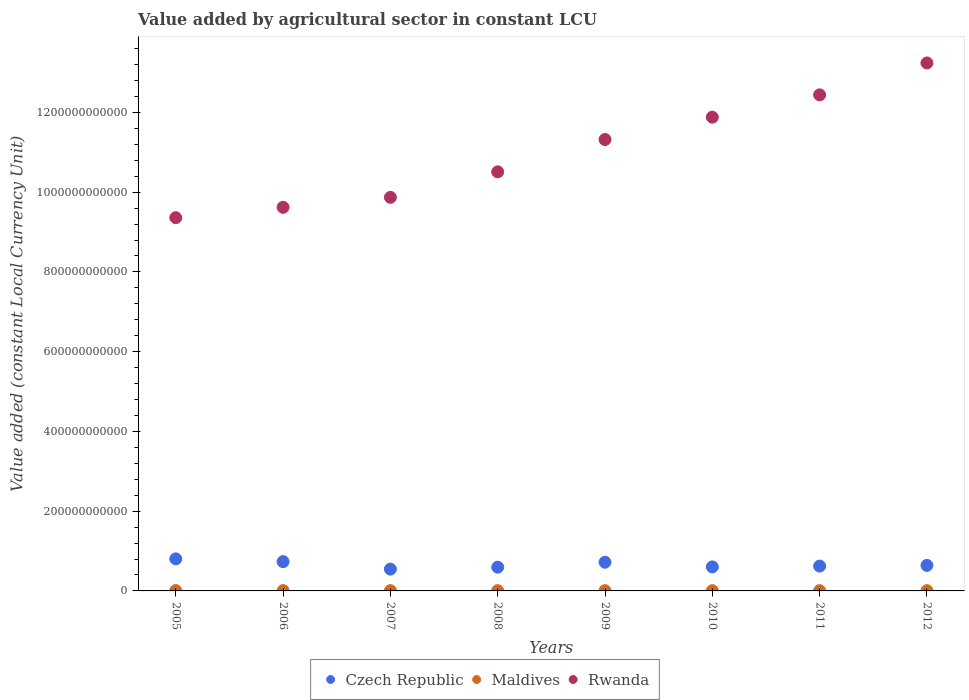How many different coloured dotlines are there?
Keep it short and to the point. 3. What is the value added by agricultural sector in Czech Republic in 2006?
Your answer should be compact. 7.35e+1. Across all years, what is the maximum value added by agricultural sector in Rwanda?
Provide a short and direct response. 1.32e+12. Across all years, what is the minimum value added by agricultural sector in Rwanda?
Your answer should be compact. 9.36e+11. What is the total value added by agricultural sector in Rwanda in the graph?
Your response must be concise. 8.82e+12. What is the difference between the value added by agricultural sector in Czech Republic in 2005 and that in 2009?
Ensure brevity in your answer.  8.48e+09. What is the difference between the value added by agricultural sector in Czech Republic in 2010 and the value added by agricultural sector in Rwanda in 2009?
Keep it short and to the point. -1.07e+12. What is the average value added by agricultural sector in Czech Republic per year?
Your response must be concise. 6.58e+1. In the year 2009, what is the difference between the value added by agricultural sector in Rwanda and value added by agricultural sector in Maldives?
Your response must be concise. 1.13e+12. In how many years, is the value added by agricultural sector in Rwanda greater than 80000000000 LCU?
Offer a very short reply. 8. What is the ratio of the value added by agricultural sector in Rwanda in 2007 to that in 2011?
Your answer should be very brief. 0.79. What is the difference between the highest and the second highest value added by agricultural sector in Rwanda?
Give a very brief answer. 8.00e+1. What is the difference between the highest and the lowest value added by agricultural sector in Rwanda?
Ensure brevity in your answer.  3.88e+11. In how many years, is the value added by agricultural sector in Rwanda greater than the average value added by agricultural sector in Rwanda taken over all years?
Ensure brevity in your answer.  4. Does the value added by agricultural sector in Maldives monotonically increase over the years?
Make the answer very short. No. Is the value added by agricultural sector in Rwanda strictly greater than the value added by agricultural sector in Czech Republic over the years?
Offer a terse response. Yes. Is the value added by agricultural sector in Rwanda strictly less than the value added by agricultural sector in Maldives over the years?
Keep it short and to the point. No. How many dotlines are there?
Provide a short and direct response. 3. How many years are there in the graph?
Your answer should be compact. 8. What is the difference between two consecutive major ticks on the Y-axis?
Ensure brevity in your answer.  2.00e+11. Where does the legend appear in the graph?
Offer a terse response. Bottom center. What is the title of the graph?
Provide a short and direct response. Value added by agricultural sector in constant LCU. What is the label or title of the X-axis?
Keep it short and to the point. Years. What is the label or title of the Y-axis?
Ensure brevity in your answer.  Value added (constant Local Currency Unit). What is the Value added (constant Local Currency Unit) of Czech Republic in 2005?
Provide a succinct answer. 8.04e+1. What is the Value added (constant Local Currency Unit) of Maldives in 2005?
Ensure brevity in your answer.  7.86e+08. What is the Value added (constant Local Currency Unit) of Rwanda in 2005?
Your response must be concise. 9.36e+11. What is the Value added (constant Local Currency Unit) of Czech Republic in 2006?
Provide a succinct answer. 7.35e+1. What is the Value added (constant Local Currency Unit) of Maldives in 2006?
Ensure brevity in your answer.  8.21e+08. What is the Value added (constant Local Currency Unit) of Rwanda in 2006?
Your answer should be very brief. 9.62e+11. What is the Value added (constant Local Currency Unit) in Czech Republic in 2007?
Make the answer very short. 5.47e+1. What is the Value added (constant Local Currency Unit) of Maldives in 2007?
Give a very brief answer. 7.23e+08. What is the Value added (constant Local Currency Unit) in Rwanda in 2007?
Provide a short and direct response. 9.87e+11. What is the Value added (constant Local Currency Unit) in Czech Republic in 2008?
Provide a short and direct response. 5.96e+1. What is the Value added (constant Local Currency Unit) in Maldives in 2008?
Offer a very short reply. 6.98e+08. What is the Value added (constant Local Currency Unit) of Rwanda in 2008?
Give a very brief answer. 1.05e+12. What is the Value added (constant Local Currency Unit) in Czech Republic in 2009?
Your answer should be very brief. 7.19e+1. What is the Value added (constant Local Currency Unit) of Maldives in 2009?
Provide a short and direct response. 6.81e+08. What is the Value added (constant Local Currency Unit) of Rwanda in 2009?
Provide a short and direct response. 1.13e+12. What is the Value added (constant Local Currency Unit) of Czech Republic in 2010?
Offer a terse response. 6.02e+1. What is the Value added (constant Local Currency Unit) in Maldives in 2010?
Make the answer very short. 6.75e+08. What is the Value added (constant Local Currency Unit) of Rwanda in 2010?
Offer a very short reply. 1.19e+12. What is the Value added (constant Local Currency Unit) of Czech Republic in 2011?
Offer a very short reply. 6.22e+1. What is the Value added (constant Local Currency Unit) of Maldives in 2011?
Provide a short and direct response. 6.82e+08. What is the Value added (constant Local Currency Unit) of Rwanda in 2011?
Keep it short and to the point. 1.24e+12. What is the Value added (constant Local Currency Unit) in Czech Republic in 2012?
Make the answer very short. 6.41e+1. What is the Value added (constant Local Currency Unit) of Maldives in 2012?
Your response must be concise. 6.82e+08. What is the Value added (constant Local Currency Unit) in Rwanda in 2012?
Your answer should be very brief. 1.32e+12. Across all years, what is the maximum Value added (constant Local Currency Unit) in Czech Republic?
Offer a very short reply. 8.04e+1. Across all years, what is the maximum Value added (constant Local Currency Unit) in Maldives?
Your response must be concise. 8.21e+08. Across all years, what is the maximum Value added (constant Local Currency Unit) in Rwanda?
Provide a succinct answer. 1.32e+12. Across all years, what is the minimum Value added (constant Local Currency Unit) of Czech Republic?
Your response must be concise. 5.47e+1. Across all years, what is the minimum Value added (constant Local Currency Unit) in Maldives?
Offer a terse response. 6.75e+08. Across all years, what is the minimum Value added (constant Local Currency Unit) in Rwanda?
Ensure brevity in your answer.  9.36e+11. What is the total Value added (constant Local Currency Unit) of Czech Republic in the graph?
Keep it short and to the point. 5.27e+11. What is the total Value added (constant Local Currency Unit) in Maldives in the graph?
Offer a terse response. 5.75e+09. What is the total Value added (constant Local Currency Unit) in Rwanda in the graph?
Your answer should be compact. 8.82e+12. What is the difference between the Value added (constant Local Currency Unit) of Czech Republic in 2005 and that in 2006?
Keep it short and to the point. 6.90e+09. What is the difference between the Value added (constant Local Currency Unit) in Maldives in 2005 and that in 2006?
Give a very brief answer. -3.46e+07. What is the difference between the Value added (constant Local Currency Unit) in Rwanda in 2005 and that in 2006?
Offer a very short reply. -2.60e+1. What is the difference between the Value added (constant Local Currency Unit) of Czech Republic in 2005 and that in 2007?
Provide a short and direct response. 2.57e+1. What is the difference between the Value added (constant Local Currency Unit) in Maldives in 2005 and that in 2007?
Your answer should be very brief. 6.33e+07. What is the difference between the Value added (constant Local Currency Unit) of Rwanda in 2005 and that in 2007?
Offer a very short reply. -5.10e+1. What is the difference between the Value added (constant Local Currency Unit) in Czech Republic in 2005 and that in 2008?
Your answer should be compact. 2.08e+1. What is the difference between the Value added (constant Local Currency Unit) in Maldives in 2005 and that in 2008?
Your answer should be very brief. 8.78e+07. What is the difference between the Value added (constant Local Currency Unit) in Rwanda in 2005 and that in 2008?
Provide a short and direct response. -1.15e+11. What is the difference between the Value added (constant Local Currency Unit) of Czech Republic in 2005 and that in 2009?
Your answer should be very brief. 8.48e+09. What is the difference between the Value added (constant Local Currency Unit) in Maldives in 2005 and that in 2009?
Ensure brevity in your answer.  1.05e+08. What is the difference between the Value added (constant Local Currency Unit) in Rwanda in 2005 and that in 2009?
Offer a very short reply. -1.96e+11. What is the difference between the Value added (constant Local Currency Unit) of Czech Republic in 2005 and that in 2010?
Offer a very short reply. 2.02e+1. What is the difference between the Value added (constant Local Currency Unit) of Maldives in 2005 and that in 2010?
Give a very brief answer. 1.11e+08. What is the difference between the Value added (constant Local Currency Unit) in Rwanda in 2005 and that in 2010?
Your response must be concise. -2.52e+11. What is the difference between the Value added (constant Local Currency Unit) of Czech Republic in 2005 and that in 2011?
Provide a succinct answer. 1.82e+1. What is the difference between the Value added (constant Local Currency Unit) in Maldives in 2005 and that in 2011?
Make the answer very short. 1.04e+08. What is the difference between the Value added (constant Local Currency Unit) of Rwanda in 2005 and that in 2011?
Keep it short and to the point. -3.08e+11. What is the difference between the Value added (constant Local Currency Unit) in Czech Republic in 2005 and that in 2012?
Your answer should be compact. 1.63e+1. What is the difference between the Value added (constant Local Currency Unit) in Maldives in 2005 and that in 2012?
Provide a succinct answer. 1.04e+08. What is the difference between the Value added (constant Local Currency Unit) in Rwanda in 2005 and that in 2012?
Provide a succinct answer. -3.88e+11. What is the difference between the Value added (constant Local Currency Unit) of Czech Republic in 2006 and that in 2007?
Offer a very short reply. 1.88e+1. What is the difference between the Value added (constant Local Currency Unit) of Maldives in 2006 and that in 2007?
Your answer should be compact. 9.79e+07. What is the difference between the Value added (constant Local Currency Unit) in Rwanda in 2006 and that in 2007?
Keep it short and to the point. -2.50e+1. What is the difference between the Value added (constant Local Currency Unit) in Czech Republic in 2006 and that in 2008?
Offer a terse response. 1.39e+1. What is the difference between the Value added (constant Local Currency Unit) of Maldives in 2006 and that in 2008?
Provide a succinct answer. 1.22e+08. What is the difference between the Value added (constant Local Currency Unit) in Rwanda in 2006 and that in 2008?
Offer a very short reply. -8.90e+1. What is the difference between the Value added (constant Local Currency Unit) in Czech Republic in 2006 and that in 2009?
Keep it short and to the point. 1.57e+09. What is the difference between the Value added (constant Local Currency Unit) of Maldives in 2006 and that in 2009?
Offer a very short reply. 1.40e+08. What is the difference between the Value added (constant Local Currency Unit) of Rwanda in 2006 and that in 2009?
Provide a succinct answer. -1.70e+11. What is the difference between the Value added (constant Local Currency Unit) in Czech Republic in 2006 and that in 2010?
Ensure brevity in your answer.  1.33e+1. What is the difference between the Value added (constant Local Currency Unit) in Maldives in 2006 and that in 2010?
Ensure brevity in your answer.  1.46e+08. What is the difference between the Value added (constant Local Currency Unit) of Rwanda in 2006 and that in 2010?
Give a very brief answer. -2.26e+11. What is the difference between the Value added (constant Local Currency Unit) of Czech Republic in 2006 and that in 2011?
Provide a short and direct response. 1.12e+1. What is the difference between the Value added (constant Local Currency Unit) of Maldives in 2006 and that in 2011?
Ensure brevity in your answer.  1.38e+08. What is the difference between the Value added (constant Local Currency Unit) of Rwanda in 2006 and that in 2011?
Your answer should be compact. -2.82e+11. What is the difference between the Value added (constant Local Currency Unit) of Czech Republic in 2006 and that in 2012?
Ensure brevity in your answer.  9.43e+09. What is the difference between the Value added (constant Local Currency Unit) in Maldives in 2006 and that in 2012?
Provide a succinct answer. 1.39e+08. What is the difference between the Value added (constant Local Currency Unit) in Rwanda in 2006 and that in 2012?
Your answer should be very brief. -3.62e+11. What is the difference between the Value added (constant Local Currency Unit) in Czech Republic in 2007 and that in 2008?
Give a very brief answer. -4.90e+09. What is the difference between the Value added (constant Local Currency Unit) of Maldives in 2007 and that in 2008?
Give a very brief answer. 2.45e+07. What is the difference between the Value added (constant Local Currency Unit) of Rwanda in 2007 and that in 2008?
Ensure brevity in your answer.  -6.40e+1. What is the difference between the Value added (constant Local Currency Unit) of Czech Republic in 2007 and that in 2009?
Your answer should be compact. -1.73e+1. What is the difference between the Value added (constant Local Currency Unit) of Maldives in 2007 and that in 2009?
Your response must be concise. 4.17e+07. What is the difference between the Value added (constant Local Currency Unit) in Rwanda in 2007 and that in 2009?
Keep it short and to the point. -1.45e+11. What is the difference between the Value added (constant Local Currency Unit) of Czech Republic in 2007 and that in 2010?
Ensure brevity in your answer.  -5.56e+09. What is the difference between the Value added (constant Local Currency Unit) of Maldives in 2007 and that in 2010?
Give a very brief answer. 4.77e+07. What is the difference between the Value added (constant Local Currency Unit) of Rwanda in 2007 and that in 2010?
Your response must be concise. -2.01e+11. What is the difference between the Value added (constant Local Currency Unit) of Czech Republic in 2007 and that in 2011?
Give a very brief answer. -7.58e+09. What is the difference between the Value added (constant Local Currency Unit) in Maldives in 2007 and that in 2011?
Provide a succinct answer. 4.06e+07. What is the difference between the Value added (constant Local Currency Unit) of Rwanda in 2007 and that in 2011?
Your answer should be very brief. -2.57e+11. What is the difference between the Value added (constant Local Currency Unit) of Czech Republic in 2007 and that in 2012?
Offer a very short reply. -9.40e+09. What is the difference between the Value added (constant Local Currency Unit) of Maldives in 2007 and that in 2012?
Your answer should be compact. 4.09e+07. What is the difference between the Value added (constant Local Currency Unit) of Rwanda in 2007 and that in 2012?
Your answer should be very brief. -3.37e+11. What is the difference between the Value added (constant Local Currency Unit) of Czech Republic in 2008 and that in 2009?
Offer a very short reply. -1.24e+1. What is the difference between the Value added (constant Local Currency Unit) of Maldives in 2008 and that in 2009?
Make the answer very short. 1.72e+07. What is the difference between the Value added (constant Local Currency Unit) in Rwanda in 2008 and that in 2009?
Provide a short and direct response. -8.10e+1. What is the difference between the Value added (constant Local Currency Unit) in Czech Republic in 2008 and that in 2010?
Your answer should be compact. -6.62e+08. What is the difference between the Value added (constant Local Currency Unit) of Maldives in 2008 and that in 2010?
Provide a short and direct response. 2.32e+07. What is the difference between the Value added (constant Local Currency Unit) of Rwanda in 2008 and that in 2010?
Provide a succinct answer. -1.37e+11. What is the difference between the Value added (constant Local Currency Unit) in Czech Republic in 2008 and that in 2011?
Provide a short and direct response. -2.68e+09. What is the difference between the Value added (constant Local Currency Unit) in Maldives in 2008 and that in 2011?
Provide a succinct answer. 1.60e+07. What is the difference between the Value added (constant Local Currency Unit) in Rwanda in 2008 and that in 2011?
Provide a short and direct response. -1.93e+11. What is the difference between the Value added (constant Local Currency Unit) of Czech Republic in 2008 and that in 2012?
Ensure brevity in your answer.  -4.50e+09. What is the difference between the Value added (constant Local Currency Unit) of Maldives in 2008 and that in 2012?
Keep it short and to the point. 1.63e+07. What is the difference between the Value added (constant Local Currency Unit) in Rwanda in 2008 and that in 2012?
Offer a very short reply. -2.73e+11. What is the difference between the Value added (constant Local Currency Unit) of Czech Republic in 2009 and that in 2010?
Your answer should be compact. 1.17e+1. What is the difference between the Value added (constant Local Currency Unit) of Maldives in 2009 and that in 2010?
Offer a terse response. 5.98e+06. What is the difference between the Value added (constant Local Currency Unit) in Rwanda in 2009 and that in 2010?
Your response must be concise. -5.60e+1. What is the difference between the Value added (constant Local Currency Unit) of Czech Republic in 2009 and that in 2011?
Your answer should be compact. 9.68e+09. What is the difference between the Value added (constant Local Currency Unit) of Maldives in 2009 and that in 2011?
Your answer should be compact. -1.15e+06. What is the difference between the Value added (constant Local Currency Unit) in Rwanda in 2009 and that in 2011?
Your answer should be compact. -1.12e+11. What is the difference between the Value added (constant Local Currency Unit) in Czech Republic in 2009 and that in 2012?
Give a very brief answer. 7.86e+09. What is the difference between the Value added (constant Local Currency Unit) of Maldives in 2009 and that in 2012?
Provide a short and direct response. -8.87e+05. What is the difference between the Value added (constant Local Currency Unit) of Rwanda in 2009 and that in 2012?
Offer a very short reply. -1.92e+11. What is the difference between the Value added (constant Local Currency Unit) in Czech Republic in 2010 and that in 2011?
Keep it short and to the point. -2.02e+09. What is the difference between the Value added (constant Local Currency Unit) of Maldives in 2010 and that in 2011?
Offer a very short reply. -7.13e+06. What is the difference between the Value added (constant Local Currency Unit) in Rwanda in 2010 and that in 2011?
Keep it short and to the point. -5.60e+1. What is the difference between the Value added (constant Local Currency Unit) of Czech Republic in 2010 and that in 2012?
Make the answer very short. -3.84e+09. What is the difference between the Value added (constant Local Currency Unit) of Maldives in 2010 and that in 2012?
Offer a very short reply. -6.86e+06. What is the difference between the Value added (constant Local Currency Unit) of Rwanda in 2010 and that in 2012?
Provide a succinct answer. -1.36e+11. What is the difference between the Value added (constant Local Currency Unit) in Czech Republic in 2011 and that in 2012?
Your response must be concise. -1.82e+09. What is the difference between the Value added (constant Local Currency Unit) of Maldives in 2011 and that in 2012?
Ensure brevity in your answer.  2.63e+05. What is the difference between the Value added (constant Local Currency Unit) of Rwanda in 2011 and that in 2012?
Offer a terse response. -8.00e+1. What is the difference between the Value added (constant Local Currency Unit) of Czech Republic in 2005 and the Value added (constant Local Currency Unit) of Maldives in 2006?
Provide a short and direct response. 7.96e+1. What is the difference between the Value added (constant Local Currency Unit) of Czech Republic in 2005 and the Value added (constant Local Currency Unit) of Rwanda in 2006?
Offer a terse response. -8.82e+11. What is the difference between the Value added (constant Local Currency Unit) in Maldives in 2005 and the Value added (constant Local Currency Unit) in Rwanda in 2006?
Offer a terse response. -9.61e+11. What is the difference between the Value added (constant Local Currency Unit) in Czech Republic in 2005 and the Value added (constant Local Currency Unit) in Maldives in 2007?
Offer a terse response. 7.97e+1. What is the difference between the Value added (constant Local Currency Unit) in Czech Republic in 2005 and the Value added (constant Local Currency Unit) in Rwanda in 2007?
Provide a short and direct response. -9.07e+11. What is the difference between the Value added (constant Local Currency Unit) of Maldives in 2005 and the Value added (constant Local Currency Unit) of Rwanda in 2007?
Provide a succinct answer. -9.86e+11. What is the difference between the Value added (constant Local Currency Unit) of Czech Republic in 2005 and the Value added (constant Local Currency Unit) of Maldives in 2008?
Offer a terse response. 7.97e+1. What is the difference between the Value added (constant Local Currency Unit) in Czech Republic in 2005 and the Value added (constant Local Currency Unit) in Rwanda in 2008?
Offer a very short reply. -9.71e+11. What is the difference between the Value added (constant Local Currency Unit) of Maldives in 2005 and the Value added (constant Local Currency Unit) of Rwanda in 2008?
Ensure brevity in your answer.  -1.05e+12. What is the difference between the Value added (constant Local Currency Unit) in Czech Republic in 2005 and the Value added (constant Local Currency Unit) in Maldives in 2009?
Offer a very short reply. 7.97e+1. What is the difference between the Value added (constant Local Currency Unit) in Czech Republic in 2005 and the Value added (constant Local Currency Unit) in Rwanda in 2009?
Give a very brief answer. -1.05e+12. What is the difference between the Value added (constant Local Currency Unit) of Maldives in 2005 and the Value added (constant Local Currency Unit) of Rwanda in 2009?
Keep it short and to the point. -1.13e+12. What is the difference between the Value added (constant Local Currency Unit) of Czech Republic in 2005 and the Value added (constant Local Currency Unit) of Maldives in 2010?
Ensure brevity in your answer.  7.97e+1. What is the difference between the Value added (constant Local Currency Unit) of Czech Republic in 2005 and the Value added (constant Local Currency Unit) of Rwanda in 2010?
Keep it short and to the point. -1.11e+12. What is the difference between the Value added (constant Local Currency Unit) of Maldives in 2005 and the Value added (constant Local Currency Unit) of Rwanda in 2010?
Give a very brief answer. -1.19e+12. What is the difference between the Value added (constant Local Currency Unit) in Czech Republic in 2005 and the Value added (constant Local Currency Unit) in Maldives in 2011?
Offer a terse response. 7.97e+1. What is the difference between the Value added (constant Local Currency Unit) in Czech Republic in 2005 and the Value added (constant Local Currency Unit) in Rwanda in 2011?
Ensure brevity in your answer.  -1.16e+12. What is the difference between the Value added (constant Local Currency Unit) of Maldives in 2005 and the Value added (constant Local Currency Unit) of Rwanda in 2011?
Your answer should be compact. -1.24e+12. What is the difference between the Value added (constant Local Currency Unit) in Czech Republic in 2005 and the Value added (constant Local Currency Unit) in Maldives in 2012?
Keep it short and to the point. 7.97e+1. What is the difference between the Value added (constant Local Currency Unit) of Czech Republic in 2005 and the Value added (constant Local Currency Unit) of Rwanda in 2012?
Your answer should be very brief. -1.24e+12. What is the difference between the Value added (constant Local Currency Unit) in Maldives in 2005 and the Value added (constant Local Currency Unit) in Rwanda in 2012?
Make the answer very short. -1.32e+12. What is the difference between the Value added (constant Local Currency Unit) of Czech Republic in 2006 and the Value added (constant Local Currency Unit) of Maldives in 2007?
Ensure brevity in your answer.  7.28e+1. What is the difference between the Value added (constant Local Currency Unit) in Czech Republic in 2006 and the Value added (constant Local Currency Unit) in Rwanda in 2007?
Offer a terse response. -9.14e+11. What is the difference between the Value added (constant Local Currency Unit) in Maldives in 2006 and the Value added (constant Local Currency Unit) in Rwanda in 2007?
Your response must be concise. -9.86e+11. What is the difference between the Value added (constant Local Currency Unit) of Czech Republic in 2006 and the Value added (constant Local Currency Unit) of Maldives in 2008?
Your answer should be compact. 7.28e+1. What is the difference between the Value added (constant Local Currency Unit) of Czech Republic in 2006 and the Value added (constant Local Currency Unit) of Rwanda in 2008?
Provide a succinct answer. -9.78e+11. What is the difference between the Value added (constant Local Currency Unit) of Maldives in 2006 and the Value added (constant Local Currency Unit) of Rwanda in 2008?
Provide a succinct answer. -1.05e+12. What is the difference between the Value added (constant Local Currency Unit) of Czech Republic in 2006 and the Value added (constant Local Currency Unit) of Maldives in 2009?
Give a very brief answer. 7.28e+1. What is the difference between the Value added (constant Local Currency Unit) in Czech Republic in 2006 and the Value added (constant Local Currency Unit) in Rwanda in 2009?
Provide a succinct answer. -1.06e+12. What is the difference between the Value added (constant Local Currency Unit) of Maldives in 2006 and the Value added (constant Local Currency Unit) of Rwanda in 2009?
Offer a very short reply. -1.13e+12. What is the difference between the Value added (constant Local Currency Unit) of Czech Republic in 2006 and the Value added (constant Local Currency Unit) of Maldives in 2010?
Offer a very short reply. 7.28e+1. What is the difference between the Value added (constant Local Currency Unit) of Czech Republic in 2006 and the Value added (constant Local Currency Unit) of Rwanda in 2010?
Give a very brief answer. -1.11e+12. What is the difference between the Value added (constant Local Currency Unit) in Maldives in 2006 and the Value added (constant Local Currency Unit) in Rwanda in 2010?
Keep it short and to the point. -1.19e+12. What is the difference between the Value added (constant Local Currency Unit) of Czech Republic in 2006 and the Value added (constant Local Currency Unit) of Maldives in 2011?
Your answer should be very brief. 7.28e+1. What is the difference between the Value added (constant Local Currency Unit) of Czech Republic in 2006 and the Value added (constant Local Currency Unit) of Rwanda in 2011?
Ensure brevity in your answer.  -1.17e+12. What is the difference between the Value added (constant Local Currency Unit) of Maldives in 2006 and the Value added (constant Local Currency Unit) of Rwanda in 2011?
Your answer should be very brief. -1.24e+12. What is the difference between the Value added (constant Local Currency Unit) in Czech Republic in 2006 and the Value added (constant Local Currency Unit) in Maldives in 2012?
Provide a short and direct response. 7.28e+1. What is the difference between the Value added (constant Local Currency Unit) in Czech Republic in 2006 and the Value added (constant Local Currency Unit) in Rwanda in 2012?
Offer a very short reply. -1.25e+12. What is the difference between the Value added (constant Local Currency Unit) of Maldives in 2006 and the Value added (constant Local Currency Unit) of Rwanda in 2012?
Make the answer very short. -1.32e+12. What is the difference between the Value added (constant Local Currency Unit) of Czech Republic in 2007 and the Value added (constant Local Currency Unit) of Maldives in 2008?
Ensure brevity in your answer.  5.40e+1. What is the difference between the Value added (constant Local Currency Unit) in Czech Republic in 2007 and the Value added (constant Local Currency Unit) in Rwanda in 2008?
Offer a very short reply. -9.96e+11. What is the difference between the Value added (constant Local Currency Unit) in Maldives in 2007 and the Value added (constant Local Currency Unit) in Rwanda in 2008?
Your answer should be compact. -1.05e+12. What is the difference between the Value added (constant Local Currency Unit) of Czech Republic in 2007 and the Value added (constant Local Currency Unit) of Maldives in 2009?
Offer a very short reply. 5.40e+1. What is the difference between the Value added (constant Local Currency Unit) in Czech Republic in 2007 and the Value added (constant Local Currency Unit) in Rwanda in 2009?
Your answer should be very brief. -1.08e+12. What is the difference between the Value added (constant Local Currency Unit) in Maldives in 2007 and the Value added (constant Local Currency Unit) in Rwanda in 2009?
Your answer should be compact. -1.13e+12. What is the difference between the Value added (constant Local Currency Unit) in Czech Republic in 2007 and the Value added (constant Local Currency Unit) in Maldives in 2010?
Keep it short and to the point. 5.40e+1. What is the difference between the Value added (constant Local Currency Unit) of Czech Republic in 2007 and the Value added (constant Local Currency Unit) of Rwanda in 2010?
Your answer should be very brief. -1.13e+12. What is the difference between the Value added (constant Local Currency Unit) in Maldives in 2007 and the Value added (constant Local Currency Unit) in Rwanda in 2010?
Your response must be concise. -1.19e+12. What is the difference between the Value added (constant Local Currency Unit) of Czech Republic in 2007 and the Value added (constant Local Currency Unit) of Maldives in 2011?
Your response must be concise. 5.40e+1. What is the difference between the Value added (constant Local Currency Unit) of Czech Republic in 2007 and the Value added (constant Local Currency Unit) of Rwanda in 2011?
Provide a short and direct response. -1.19e+12. What is the difference between the Value added (constant Local Currency Unit) of Maldives in 2007 and the Value added (constant Local Currency Unit) of Rwanda in 2011?
Offer a terse response. -1.24e+12. What is the difference between the Value added (constant Local Currency Unit) of Czech Republic in 2007 and the Value added (constant Local Currency Unit) of Maldives in 2012?
Your answer should be compact. 5.40e+1. What is the difference between the Value added (constant Local Currency Unit) of Czech Republic in 2007 and the Value added (constant Local Currency Unit) of Rwanda in 2012?
Your answer should be compact. -1.27e+12. What is the difference between the Value added (constant Local Currency Unit) of Maldives in 2007 and the Value added (constant Local Currency Unit) of Rwanda in 2012?
Your answer should be very brief. -1.32e+12. What is the difference between the Value added (constant Local Currency Unit) of Czech Republic in 2008 and the Value added (constant Local Currency Unit) of Maldives in 2009?
Offer a terse response. 5.89e+1. What is the difference between the Value added (constant Local Currency Unit) of Czech Republic in 2008 and the Value added (constant Local Currency Unit) of Rwanda in 2009?
Make the answer very short. -1.07e+12. What is the difference between the Value added (constant Local Currency Unit) of Maldives in 2008 and the Value added (constant Local Currency Unit) of Rwanda in 2009?
Provide a short and direct response. -1.13e+12. What is the difference between the Value added (constant Local Currency Unit) in Czech Republic in 2008 and the Value added (constant Local Currency Unit) in Maldives in 2010?
Provide a short and direct response. 5.89e+1. What is the difference between the Value added (constant Local Currency Unit) of Czech Republic in 2008 and the Value added (constant Local Currency Unit) of Rwanda in 2010?
Your answer should be compact. -1.13e+12. What is the difference between the Value added (constant Local Currency Unit) in Maldives in 2008 and the Value added (constant Local Currency Unit) in Rwanda in 2010?
Provide a succinct answer. -1.19e+12. What is the difference between the Value added (constant Local Currency Unit) in Czech Republic in 2008 and the Value added (constant Local Currency Unit) in Maldives in 2011?
Your answer should be compact. 5.89e+1. What is the difference between the Value added (constant Local Currency Unit) of Czech Republic in 2008 and the Value added (constant Local Currency Unit) of Rwanda in 2011?
Provide a short and direct response. -1.18e+12. What is the difference between the Value added (constant Local Currency Unit) of Maldives in 2008 and the Value added (constant Local Currency Unit) of Rwanda in 2011?
Make the answer very short. -1.24e+12. What is the difference between the Value added (constant Local Currency Unit) in Czech Republic in 2008 and the Value added (constant Local Currency Unit) in Maldives in 2012?
Your answer should be very brief. 5.89e+1. What is the difference between the Value added (constant Local Currency Unit) in Czech Republic in 2008 and the Value added (constant Local Currency Unit) in Rwanda in 2012?
Your response must be concise. -1.26e+12. What is the difference between the Value added (constant Local Currency Unit) in Maldives in 2008 and the Value added (constant Local Currency Unit) in Rwanda in 2012?
Ensure brevity in your answer.  -1.32e+12. What is the difference between the Value added (constant Local Currency Unit) of Czech Republic in 2009 and the Value added (constant Local Currency Unit) of Maldives in 2010?
Your response must be concise. 7.12e+1. What is the difference between the Value added (constant Local Currency Unit) in Czech Republic in 2009 and the Value added (constant Local Currency Unit) in Rwanda in 2010?
Your answer should be very brief. -1.12e+12. What is the difference between the Value added (constant Local Currency Unit) of Maldives in 2009 and the Value added (constant Local Currency Unit) of Rwanda in 2010?
Ensure brevity in your answer.  -1.19e+12. What is the difference between the Value added (constant Local Currency Unit) of Czech Republic in 2009 and the Value added (constant Local Currency Unit) of Maldives in 2011?
Provide a short and direct response. 7.12e+1. What is the difference between the Value added (constant Local Currency Unit) of Czech Republic in 2009 and the Value added (constant Local Currency Unit) of Rwanda in 2011?
Offer a very short reply. -1.17e+12. What is the difference between the Value added (constant Local Currency Unit) of Maldives in 2009 and the Value added (constant Local Currency Unit) of Rwanda in 2011?
Keep it short and to the point. -1.24e+12. What is the difference between the Value added (constant Local Currency Unit) in Czech Republic in 2009 and the Value added (constant Local Currency Unit) in Maldives in 2012?
Make the answer very short. 7.12e+1. What is the difference between the Value added (constant Local Currency Unit) in Czech Republic in 2009 and the Value added (constant Local Currency Unit) in Rwanda in 2012?
Offer a terse response. -1.25e+12. What is the difference between the Value added (constant Local Currency Unit) in Maldives in 2009 and the Value added (constant Local Currency Unit) in Rwanda in 2012?
Your answer should be compact. -1.32e+12. What is the difference between the Value added (constant Local Currency Unit) in Czech Republic in 2010 and the Value added (constant Local Currency Unit) in Maldives in 2011?
Your answer should be very brief. 5.95e+1. What is the difference between the Value added (constant Local Currency Unit) of Czech Republic in 2010 and the Value added (constant Local Currency Unit) of Rwanda in 2011?
Offer a terse response. -1.18e+12. What is the difference between the Value added (constant Local Currency Unit) in Maldives in 2010 and the Value added (constant Local Currency Unit) in Rwanda in 2011?
Offer a very short reply. -1.24e+12. What is the difference between the Value added (constant Local Currency Unit) in Czech Republic in 2010 and the Value added (constant Local Currency Unit) in Maldives in 2012?
Your answer should be compact. 5.95e+1. What is the difference between the Value added (constant Local Currency Unit) of Czech Republic in 2010 and the Value added (constant Local Currency Unit) of Rwanda in 2012?
Your response must be concise. -1.26e+12. What is the difference between the Value added (constant Local Currency Unit) in Maldives in 2010 and the Value added (constant Local Currency Unit) in Rwanda in 2012?
Make the answer very short. -1.32e+12. What is the difference between the Value added (constant Local Currency Unit) in Czech Republic in 2011 and the Value added (constant Local Currency Unit) in Maldives in 2012?
Offer a terse response. 6.16e+1. What is the difference between the Value added (constant Local Currency Unit) in Czech Republic in 2011 and the Value added (constant Local Currency Unit) in Rwanda in 2012?
Your answer should be compact. -1.26e+12. What is the difference between the Value added (constant Local Currency Unit) in Maldives in 2011 and the Value added (constant Local Currency Unit) in Rwanda in 2012?
Offer a terse response. -1.32e+12. What is the average Value added (constant Local Currency Unit) in Czech Republic per year?
Provide a succinct answer. 6.58e+1. What is the average Value added (constant Local Currency Unit) of Maldives per year?
Give a very brief answer. 7.19e+08. What is the average Value added (constant Local Currency Unit) in Rwanda per year?
Your answer should be very brief. 1.10e+12. In the year 2005, what is the difference between the Value added (constant Local Currency Unit) of Czech Republic and Value added (constant Local Currency Unit) of Maldives?
Keep it short and to the point. 7.96e+1. In the year 2005, what is the difference between the Value added (constant Local Currency Unit) of Czech Republic and Value added (constant Local Currency Unit) of Rwanda?
Provide a short and direct response. -8.56e+11. In the year 2005, what is the difference between the Value added (constant Local Currency Unit) of Maldives and Value added (constant Local Currency Unit) of Rwanda?
Your answer should be very brief. -9.35e+11. In the year 2006, what is the difference between the Value added (constant Local Currency Unit) of Czech Republic and Value added (constant Local Currency Unit) of Maldives?
Keep it short and to the point. 7.27e+1. In the year 2006, what is the difference between the Value added (constant Local Currency Unit) in Czech Republic and Value added (constant Local Currency Unit) in Rwanda?
Offer a very short reply. -8.89e+11. In the year 2006, what is the difference between the Value added (constant Local Currency Unit) of Maldives and Value added (constant Local Currency Unit) of Rwanda?
Your answer should be very brief. -9.61e+11. In the year 2007, what is the difference between the Value added (constant Local Currency Unit) of Czech Republic and Value added (constant Local Currency Unit) of Maldives?
Your answer should be compact. 5.39e+1. In the year 2007, what is the difference between the Value added (constant Local Currency Unit) of Czech Republic and Value added (constant Local Currency Unit) of Rwanda?
Your answer should be compact. -9.32e+11. In the year 2007, what is the difference between the Value added (constant Local Currency Unit) of Maldives and Value added (constant Local Currency Unit) of Rwanda?
Make the answer very short. -9.86e+11. In the year 2008, what is the difference between the Value added (constant Local Currency Unit) of Czech Republic and Value added (constant Local Currency Unit) of Maldives?
Your answer should be compact. 5.89e+1. In the year 2008, what is the difference between the Value added (constant Local Currency Unit) of Czech Republic and Value added (constant Local Currency Unit) of Rwanda?
Your answer should be compact. -9.91e+11. In the year 2008, what is the difference between the Value added (constant Local Currency Unit) of Maldives and Value added (constant Local Currency Unit) of Rwanda?
Your answer should be compact. -1.05e+12. In the year 2009, what is the difference between the Value added (constant Local Currency Unit) of Czech Republic and Value added (constant Local Currency Unit) of Maldives?
Ensure brevity in your answer.  7.12e+1. In the year 2009, what is the difference between the Value added (constant Local Currency Unit) of Czech Republic and Value added (constant Local Currency Unit) of Rwanda?
Your answer should be compact. -1.06e+12. In the year 2009, what is the difference between the Value added (constant Local Currency Unit) in Maldives and Value added (constant Local Currency Unit) in Rwanda?
Provide a short and direct response. -1.13e+12. In the year 2010, what is the difference between the Value added (constant Local Currency Unit) of Czech Republic and Value added (constant Local Currency Unit) of Maldives?
Give a very brief answer. 5.95e+1. In the year 2010, what is the difference between the Value added (constant Local Currency Unit) of Czech Republic and Value added (constant Local Currency Unit) of Rwanda?
Provide a short and direct response. -1.13e+12. In the year 2010, what is the difference between the Value added (constant Local Currency Unit) of Maldives and Value added (constant Local Currency Unit) of Rwanda?
Your answer should be compact. -1.19e+12. In the year 2011, what is the difference between the Value added (constant Local Currency Unit) in Czech Republic and Value added (constant Local Currency Unit) in Maldives?
Your answer should be compact. 6.16e+1. In the year 2011, what is the difference between the Value added (constant Local Currency Unit) of Czech Republic and Value added (constant Local Currency Unit) of Rwanda?
Make the answer very short. -1.18e+12. In the year 2011, what is the difference between the Value added (constant Local Currency Unit) of Maldives and Value added (constant Local Currency Unit) of Rwanda?
Offer a very short reply. -1.24e+12. In the year 2012, what is the difference between the Value added (constant Local Currency Unit) of Czech Republic and Value added (constant Local Currency Unit) of Maldives?
Provide a short and direct response. 6.34e+1. In the year 2012, what is the difference between the Value added (constant Local Currency Unit) in Czech Republic and Value added (constant Local Currency Unit) in Rwanda?
Your answer should be compact. -1.26e+12. In the year 2012, what is the difference between the Value added (constant Local Currency Unit) of Maldives and Value added (constant Local Currency Unit) of Rwanda?
Ensure brevity in your answer.  -1.32e+12. What is the ratio of the Value added (constant Local Currency Unit) in Czech Republic in 2005 to that in 2006?
Provide a short and direct response. 1.09. What is the ratio of the Value added (constant Local Currency Unit) of Maldives in 2005 to that in 2006?
Make the answer very short. 0.96. What is the ratio of the Value added (constant Local Currency Unit) of Rwanda in 2005 to that in 2006?
Offer a very short reply. 0.97. What is the ratio of the Value added (constant Local Currency Unit) of Czech Republic in 2005 to that in 2007?
Your response must be concise. 1.47. What is the ratio of the Value added (constant Local Currency Unit) in Maldives in 2005 to that in 2007?
Give a very brief answer. 1.09. What is the ratio of the Value added (constant Local Currency Unit) in Rwanda in 2005 to that in 2007?
Offer a very short reply. 0.95. What is the ratio of the Value added (constant Local Currency Unit) in Czech Republic in 2005 to that in 2008?
Your answer should be very brief. 1.35. What is the ratio of the Value added (constant Local Currency Unit) in Maldives in 2005 to that in 2008?
Your response must be concise. 1.13. What is the ratio of the Value added (constant Local Currency Unit) of Rwanda in 2005 to that in 2008?
Provide a succinct answer. 0.89. What is the ratio of the Value added (constant Local Currency Unit) of Czech Republic in 2005 to that in 2009?
Make the answer very short. 1.12. What is the ratio of the Value added (constant Local Currency Unit) in Maldives in 2005 to that in 2009?
Provide a succinct answer. 1.15. What is the ratio of the Value added (constant Local Currency Unit) of Rwanda in 2005 to that in 2009?
Your answer should be compact. 0.83. What is the ratio of the Value added (constant Local Currency Unit) of Czech Republic in 2005 to that in 2010?
Provide a short and direct response. 1.33. What is the ratio of the Value added (constant Local Currency Unit) of Maldives in 2005 to that in 2010?
Provide a succinct answer. 1.16. What is the ratio of the Value added (constant Local Currency Unit) of Rwanda in 2005 to that in 2010?
Offer a very short reply. 0.79. What is the ratio of the Value added (constant Local Currency Unit) in Czech Republic in 2005 to that in 2011?
Offer a very short reply. 1.29. What is the ratio of the Value added (constant Local Currency Unit) in Maldives in 2005 to that in 2011?
Offer a very short reply. 1.15. What is the ratio of the Value added (constant Local Currency Unit) of Rwanda in 2005 to that in 2011?
Make the answer very short. 0.75. What is the ratio of the Value added (constant Local Currency Unit) in Czech Republic in 2005 to that in 2012?
Give a very brief answer. 1.25. What is the ratio of the Value added (constant Local Currency Unit) of Maldives in 2005 to that in 2012?
Provide a short and direct response. 1.15. What is the ratio of the Value added (constant Local Currency Unit) in Rwanda in 2005 to that in 2012?
Your response must be concise. 0.71. What is the ratio of the Value added (constant Local Currency Unit) of Czech Republic in 2006 to that in 2007?
Your answer should be compact. 1.34. What is the ratio of the Value added (constant Local Currency Unit) in Maldives in 2006 to that in 2007?
Offer a terse response. 1.14. What is the ratio of the Value added (constant Local Currency Unit) of Rwanda in 2006 to that in 2007?
Your answer should be compact. 0.97. What is the ratio of the Value added (constant Local Currency Unit) in Czech Republic in 2006 to that in 2008?
Ensure brevity in your answer.  1.23. What is the ratio of the Value added (constant Local Currency Unit) in Maldives in 2006 to that in 2008?
Provide a succinct answer. 1.18. What is the ratio of the Value added (constant Local Currency Unit) in Rwanda in 2006 to that in 2008?
Make the answer very short. 0.92. What is the ratio of the Value added (constant Local Currency Unit) in Czech Republic in 2006 to that in 2009?
Ensure brevity in your answer.  1.02. What is the ratio of the Value added (constant Local Currency Unit) in Maldives in 2006 to that in 2009?
Keep it short and to the point. 1.21. What is the ratio of the Value added (constant Local Currency Unit) in Rwanda in 2006 to that in 2009?
Provide a short and direct response. 0.85. What is the ratio of the Value added (constant Local Currency Unit) of Czech Republic in 2006 to that in 2010?
Make the answer very short. 1.22. What is the ratio of the Value added (constant Local Currency Unit) in Maldives in 2006 to that in 2010?
Keep it short and to the point. 1.22. What is the ratio of the Value added (constant Local Currency Unit) of Rwanda in 2006 to that in 2010?
Your response must be concise. 0.81. What is the ratio of the Value added (constant Local Currency Unit) of Czech Republic in 2006 to that in 2011?
Your response must be concise. 1.18. What is the ratio of the Value added (constant Local Currency Unit) in Maldives in 2006 to that in 2011?
Your answer should be compact. 1.2. What is the ratio of the Value added (constant Local Currency Unit) of Rwanda in 2006 to that in 2011?
Provide a succinct answer. 0.77. What is the ratio of the Value added (constant Local Currency Unit) of Czech Republic in 2006 to that in 2012?
Ensure brevity in your answer.  1.15. What is the ratio of the Value added (constant Local Currency Unit) in Maldives in 2006 to that in 2012?
Provide a succinct answer. 1.2. What is the ratio of the Value added (constant Local Currency Unit) of Rwanda in 2006 to that in 2012?
Your response must be concise. 0.73. What is the ratio of the Value added (constant Local Currency Unit) of Czech Republic in 2007 to that in 2008?
Offer a very short reply. 0.92. What is the ratio of the Value added (constant Local Currency Unit) of Maldives in 2007 to that in 2008?
Provide a short and direct response. 1.04. What is the ratio of the Value added (constant Local Currency Unit) in Rwanda in 2007 to that in 2008?
Your answer should be very brief. 0.94. What is the ratio of the Value added (constant Local Currency Unit) in Czech Republic in 2007 to that in 2009?
Give a very brief answer. 0.76. What is the ratio of the Value added (constant Local Currency Unit) of Maldives in 2007 to that in 2009?
Your response must be concise. 1.06. What is the ratio of the Value added (constant Local Currency Unit) in Rwanda in 2007 to that in 2009?
Your answer should be very brief. 0.87. What is the ratio of the Value added (constant Local Currency Unit) of Czech Republic in 2007 to that in 2010?
Provide a short and direct response. 0.91. What is the ratio of the Value added (constant Local Currency Unit) of Maldives in 2007 to that in 2010?
Make the answer very short. 1.07. What is the ratio of the Value added (constant Local Currency Unit) of Rwanda in 2007 to that in 2010?
Give a very brief answer. 0.83. What is the ratio of the Value added (constant Local Currency Unit) in Czech Republic in 2007 to that in 2011?
Keep it short and to the point. 0.88. What is the ratio of the Value added (constant Local Currency Unit) in Maldives in 2007 to that in 2011?
Make the answer very short. 1.06. What is the ratio of the Value added (constant Local Currency Unit) in Rwanda in 2007 to that in 2011?
Ensure brevity in your answer.  0.79. What is the ratio of the Value added (constant Local Currency Unit) in Czech Republic in 2007 to that in 2012?
Your answer should be very brief. 0.85. What is the ratio of the Value added (constant Local Currency Unit) of Maldives in 2007 to that in 2012?
Keep it short and to the point. 1.06. What is the ratio of the Value added (constant Local Currency Unit) of Rwanda in 2007 to that in 2012?
Provide a succinct answer. 0.75. What is the ratio of the Value added (constant Local Currency Unit) of Czech Republic in 2008 to that in 2009?
Offer a terse response. 0.83. What is the ratio of the Value added (constant Local Currency Unit) of Maldives in 2008 to that in 2009?
Keep it short and to the point. 1.03. What is the ratio of the Value added (constant Local Currency Unit) of Rwanda in 2008 to that in 2009?
Provide a short and direct response. 0.93. What is the ratio of the Value added (constant Local Currency Unit) of Czech Republic in 2008 to that in 2010?
Give a very brief answer. 0.99. What is the ratio of the Value added (constant Local Currency Unit) of Maldives in 2008 to that in 2010?
Offer a very short reply. 1.03. What is the ratio of the Value added (constant Local Currency Unit) in Rwanda in 2008 to that in 2010?
Offer a very short reply. 0.88. What is the ratio of the Value added (constant Local Currency Unit) of Czech Republic in 2008 to that in 2011?
Make the answer very short. 0.96. What is the ratio of the Value added (constant Local Currency Unit) of Maldives in 2008 to that in 2011?
Provide a short and direct response. 1.02. What is the ratio of the Value added (constant Local Currency Unit) of Rwanda in 2008 to that in 2011?
Your answer should be very brief. 0.84. What is the ratio of the Value added (constant Local Currency Unit) in Czech Republic in 2008 to that in 2012?
Make the answer very short. 0.93. What is the ratio of the Value added (constant Local Currency Unit) of Maldives in 2008 to that in 2012?
Your answer should be compact. 1.02. What is the ratio of the Value added (constant Local Currency Unit) in Rwanda in 2008 to that in 2012?
Give a very brief answer. 0.79. What is the ratio of the Value added (constant Local Currency Unit) of Czech Republic in 2009 to that in 2010?
Keep it short and to the point. 1.19. What is the ratio of the Value added (constant Local Currency Unit) of Maldives in 2009 to that in 2010?
Offer a very short reply. 1.01. What is the ratio of the Value added (constant Local Currency Unit) in Rwanda in 2009 to that in 2010?
Your answer should be compact. 0.95. What is the ratio of the Value added (constant Local Currency Unit) in Czech Republic in 2009 to that in 2011?
Keep it short and to the point. 1.16. What is the ratio of the Value added (constant Local Currency Unit) in Maldives in 2009 to that in 2011?
Keep it short and to the point. 1. What is the ratio of the Value added (constant Local Currency Unit) of Rwanda in 2009 to that in 2011?
Provide a short and direct response. 0.91. What is the ratio of the Value added (constant Local Currency Unit) in Czech Republic in 2009 to that in 2012?
Ensure brevity in your answer.  1.12. What is the ratio of the Value added (constant Local Currency Unit) of Maldives in 2009 to that in 2012?
Make the answer very short. 1. What is the ratio of the Value added (constant Local Currency Unit) in Rwanda in 2009 to that in 2012?
Make the answer very short. 0.85. What is the ratio of the Value added (constant Local Currency Unit) in Czech Republic in 2010 to that in 2011?
Provide a short and direct response. 0.97. What is the ratio of the Value added (constant Local Currency Unit) of Rwanda in 2010 to that in 2011?
Provide a short and direct response. 0.95. What is the ratio of the Value added (constant Local Currency Unit) in Czech Republic in 2010 to that in 2012?
Offer a terse response. 0.94. What is the ratio of the Value added (constant Local Currency Unit) in Maldives in 2010 to that in 2012?
Keep it short and to the point. 0.99. What is the ratio of the Value added (constant Local Currency Unit) in Rwanda in 2010 to that in 2012?
Ensure brevity in your answer.  0.9. What is the ratio of the Value added (constant Local Currency Unit) in Czech Republic in 2011 to that in 2012?
Offer a very short reply. 0.97. What is the ratio of the Value added (constant Local Currency Unit) in Rwanda in 2011 to that in 2012?
Provide a short and direct response. 0.94. What is the difference between the highest and the second highest Value added (constant Local Currency Unit) of Czech Republic?
Offer a terse response. 6.90e+09. What is the difference between the highest and the second highest Value added (constant Local Currency Unit) of Maldives?
Your response must be concise. 3.46e+07. What is the difference between the highest and the second highest Value added (constant Local Currency Unit) in Rwanda?
Give a very brief answer. 8.00e+1. What is the difference between the highest and the lowest Value added (constant Local Currency Unit) of Czech Republic?
Your answer should be very brief. 2.57e+1. What is the difference between the highest and the lowest Value added (constant Local Currency Unit) in Maldives?
Your response must be concise. 1.46e+08. What is the difference between the highest and the lowest Value added (constant Local Currency Unit) in Rwanda?
Your response must be concise. 3.88e+11. 